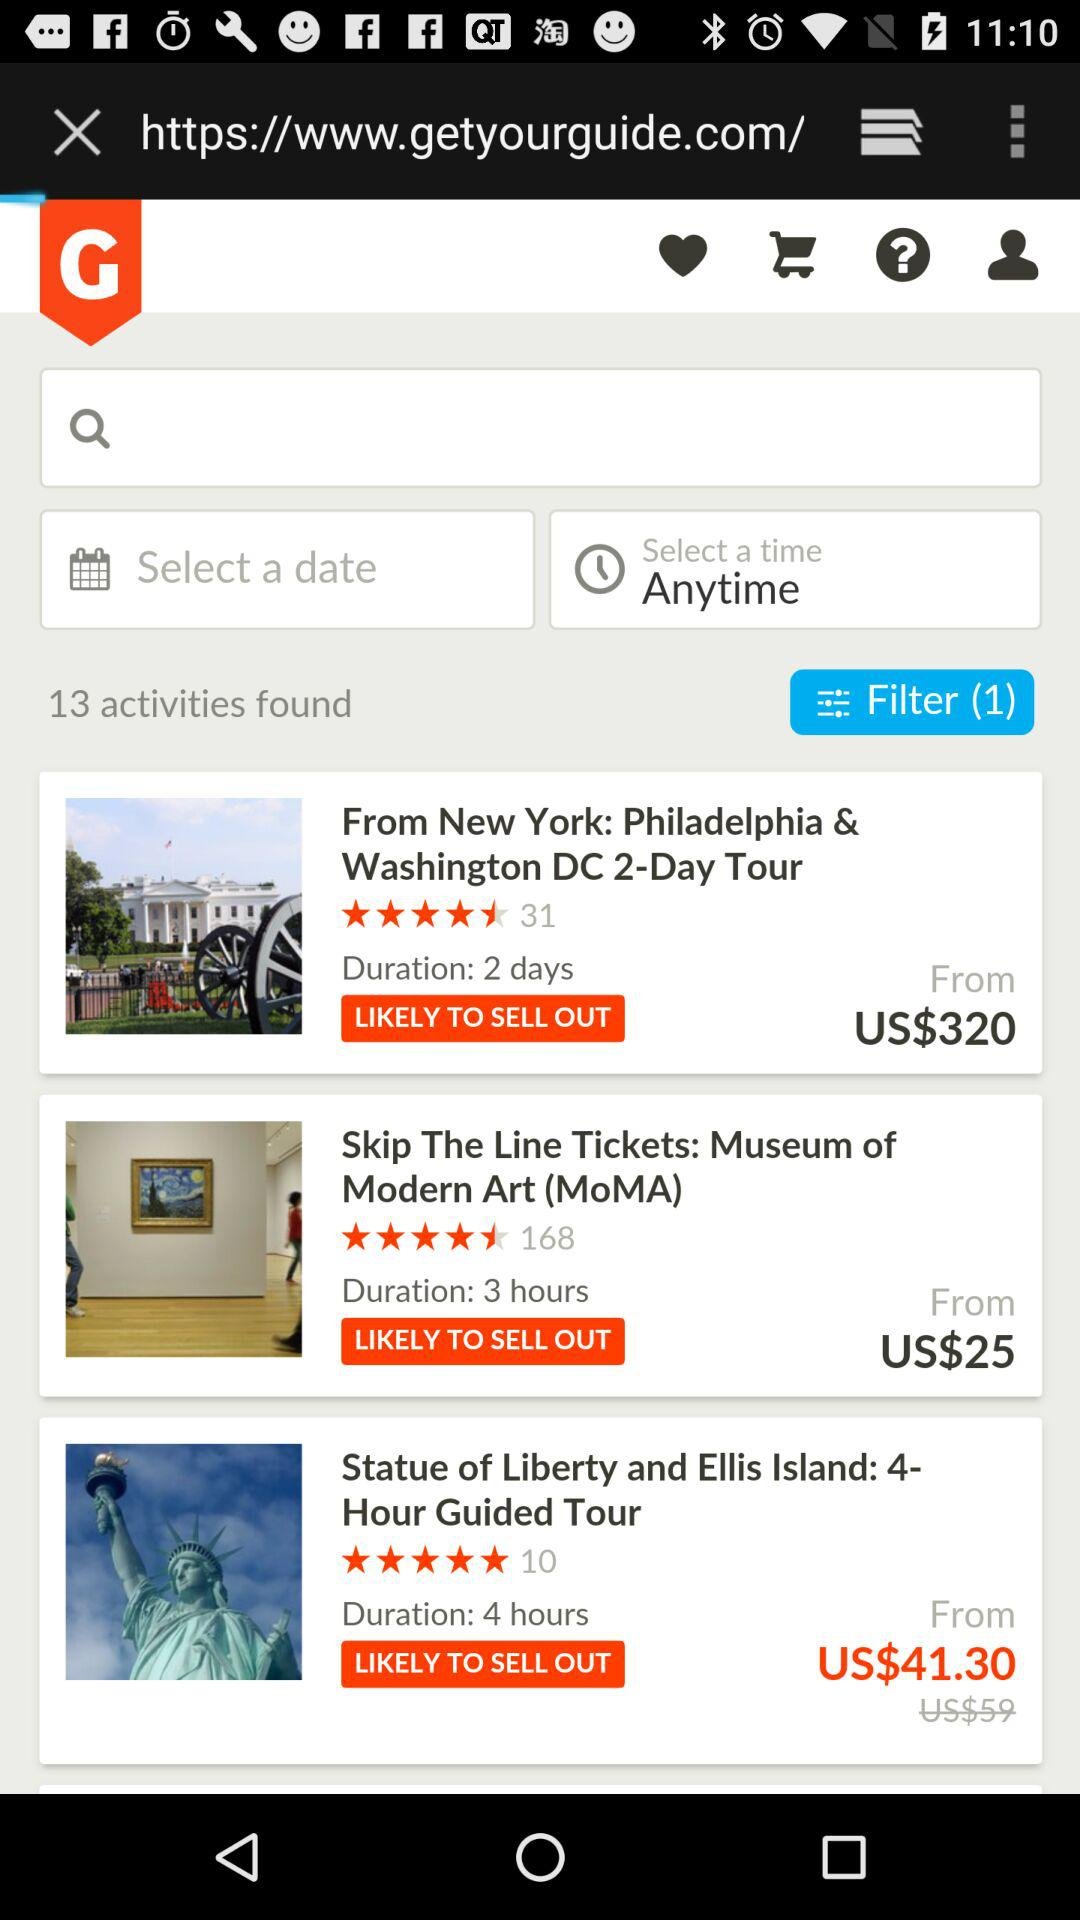How many activities in total were found on the screen? There were a total of 13 activities found on the screen. 